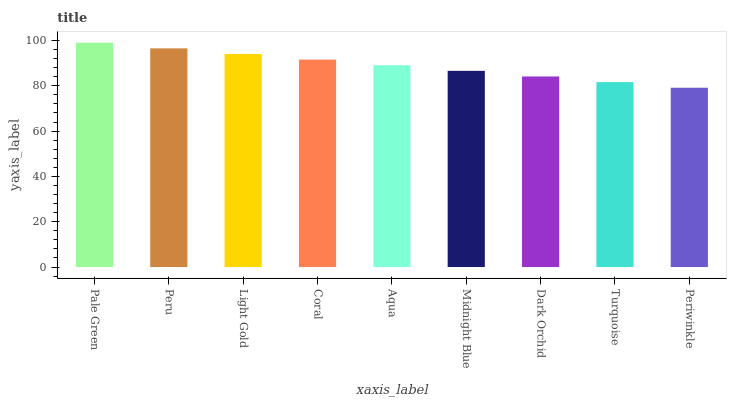Is Periwinkle the minimum?
Answer yes or no. Yes. Is Pale Green the maximum?
Answer yes or no. Yes. Is Peru the minimum?
Answer yes or no. No. Is Peru the maximum?
Answer yes or no. No. Is Pale Green greater than Peru?
Answer yes or no. Yes. Is Peru less than Pale Green?
Answer yes or no. Yes. Is Peru greater than Pale Green?
Answer yes or no. No. Is Pale Green less than Peru?
Answer yes or no. No. Is Aqua the high median?
Answer yes or no. Yes. Is Aqua the low median?
Answer yes or no. Yes. Is Light Gold the high median?
Answer yes or no. No. Is Periwinkle the low median?
Answer yes or no. No. 